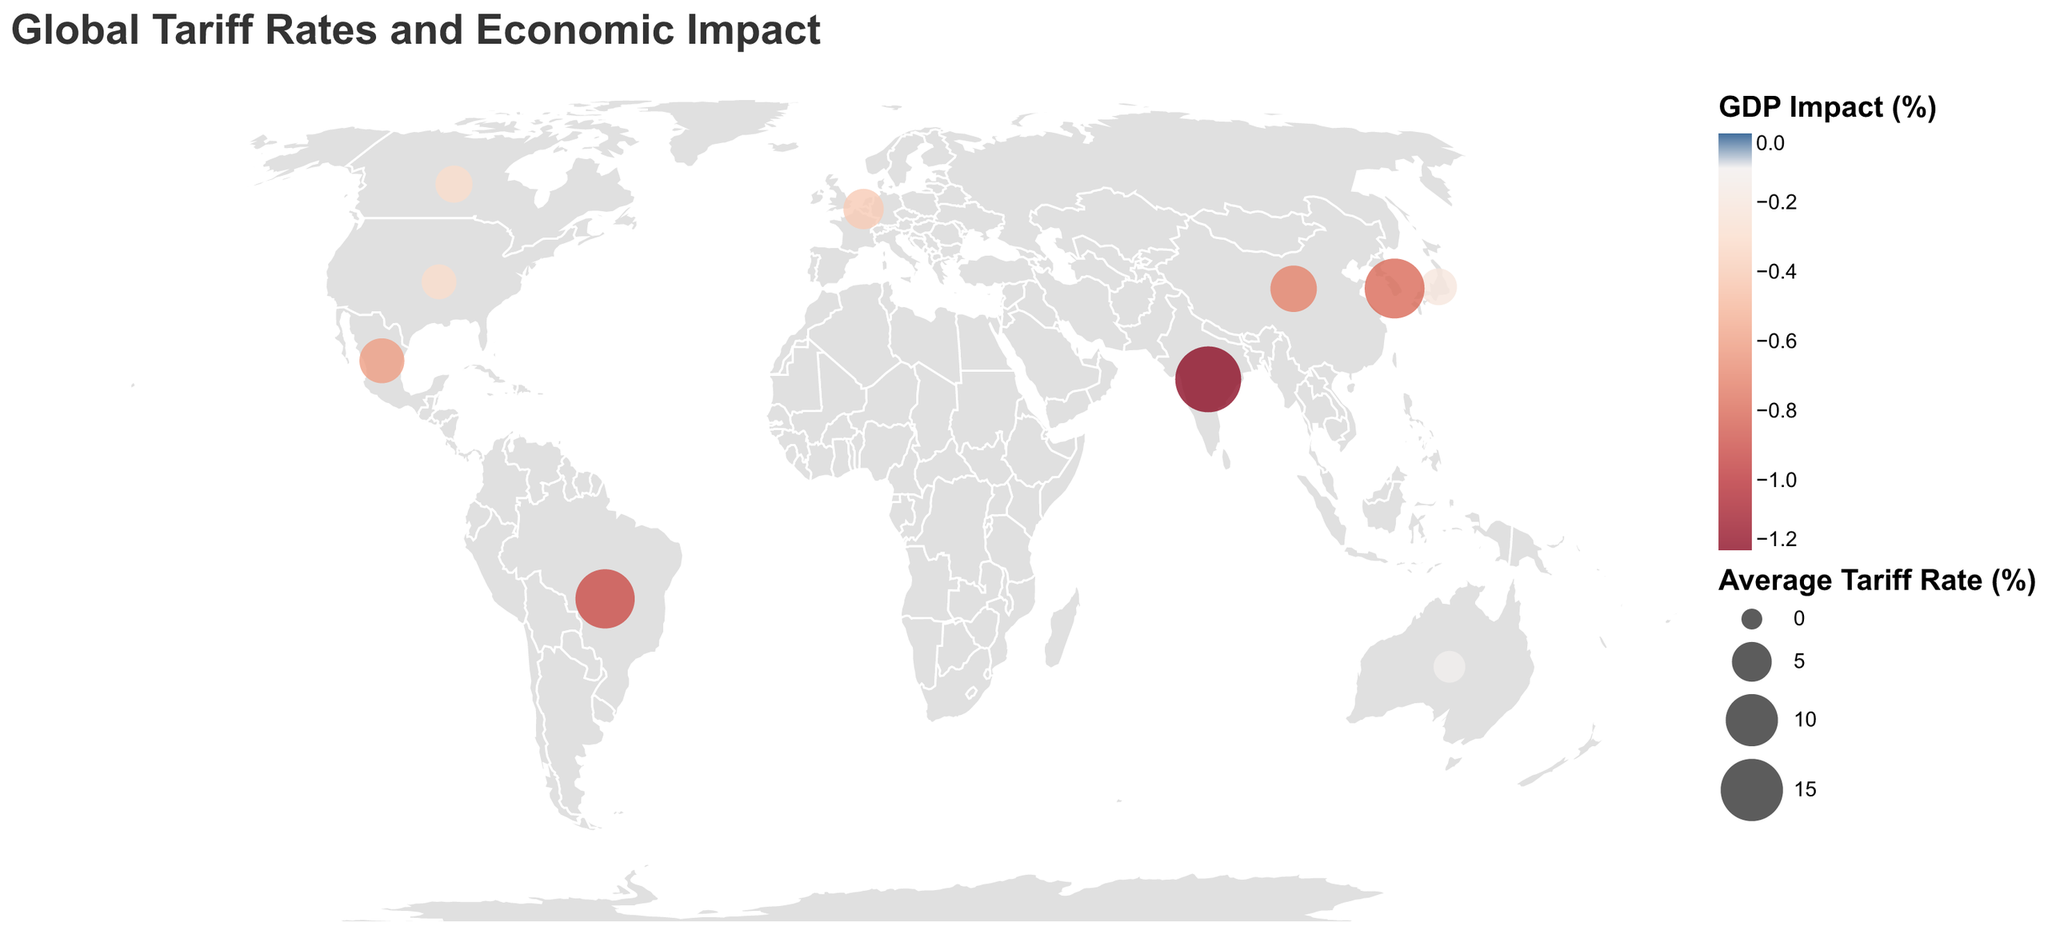How many countries have an average tariff rate above 10%? The figure shows 10 countries with their average tariff rates. By looking at the data points, the countries with tariffs above 10% are India, Brazil, and South Korea. Therefore, there are 3 countries with an average tariff rate above 10%.
Answer: 3 Which country has the highest average tariff rate? By observing the size of the circles on the map that represent the average tariff rates of each country, India has the largest circle, indicating it has the highest average tariff rate.
Answer: India What is the total GDP impact for countries with an average tariff rate below 5%? The countries with average tariff rates below 5% are the United States, Japan, Canada, and Australia. Their respective GDP impacts are -0.3%, -0.2%, -0.3%, and -0.1%. Summing these up: -0.3 + (-0.2) + (-0.3) + (-0.1) = -0.9%
Answer: -0.9% Compare the average tariff rate between the United States and China. Which one is higher? The United States has an average tariff rate of 3.4% while China has an average tariff rate of 7.5%. Clearly, China's average tariff rate is higher than that of the United States.
Answer: China Which major sector is most affected by tariffs in Brazil? The tooltip on the circle representing Brazil provides information on the major affected sector. According to this, the steel sector is the most affected in Brazil.
Answer: Steel What color represents the GDP impact scale for positive values and which for negative values? The color legend for GDP Impact (%) uses a red-blue spectrum. In this context, red represents negative values while blue represents positive values.
Answer: Red for negative, blue for positive Which country has the least impact on GDP due to tariffs? Observing the color intensity and the tooltip details, Australia, with a GDP impact of -0.1%, has the least impact among the countries shown.
Answer: Australia What is the relationship between average tariff rate and GDP impact for the majority of countries? Analyzing the tooltip data of various countries, it is evident that higher average tariff rates generally correlate with more negative GDP impacts. Examples include India (17.0%, -1.2%), Brazil (13.4%, -0.9%), and South Korea (13.7%, -0.8%).
Answer: Higher tariffs → higher negative GDP impact 